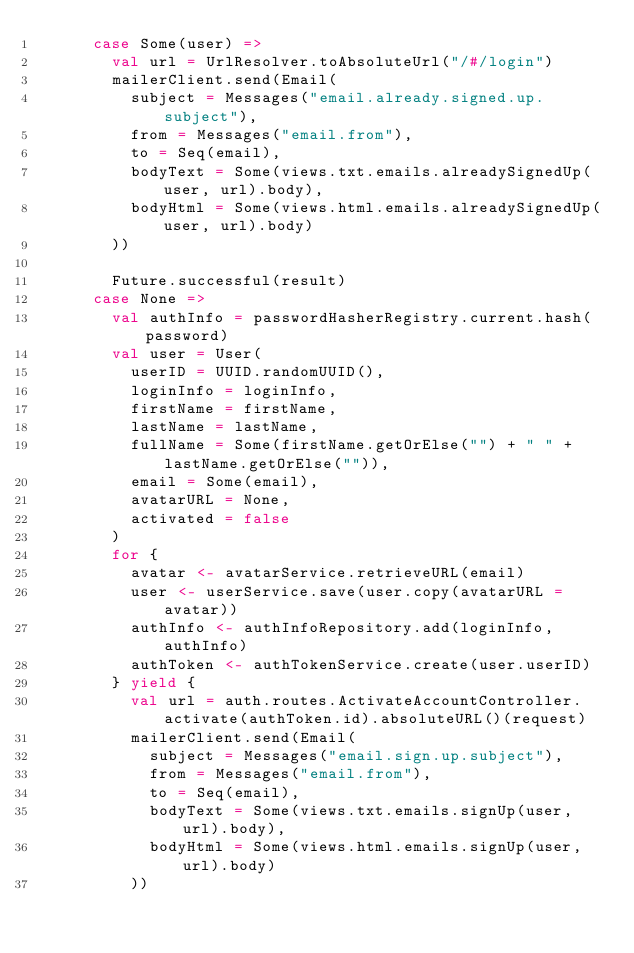Convert code to text. <code><loc_0><loc_0><loc_500><loc_500><_Scala_>      case Some(user) =>
        val url = UrlResolver.toAbsoluteUrl("/#/login")
        mailerClient.send(Email(
          subject = Messages("email.already.signed.up.subject"),
          from = Messages("email.from"),
          to = Seq(email),
          bodyText = Some(views.txt.emails.alreadySignedUp(user, url).body),
          bodyHtml = Some(views.html.emails.alreadySignedUp(user, url).body)
        ))

        Future.successful(result)
      case None =>
        val authInfo = passwordHasherRegistry.current.hash(password)
        val user = User(
          userID = UUID.randomUUID(),
          loginInfo = loginInfo,
          firstName = firstName,
          lastName = lastName,
          fullName = Some(firstName.getOrElse("") + " " + lastName.getOrElse("")),
          email = Some(email),
          avatarURL = None,
          activated = false
        )
        for {
          avatar <- avatarService.retrieveURL(email)
          user <- userService.save(user.copy(avatarURL = avatar))
          authInfo <- authInfoRepository.add(loginInfo, authInfo)
          authToken <- authTokenService.create(user.userID)
        } yield {
          val url = auth.routes.ActivateAccountController.activate(authToken.id).absoluteURL()(request)
          mailerClient.send(Email(
            subject = Messages("email.sign.up.subject"),
            from = Messages("email.from"),
            to = Seq(email),
            bodyText = Some(views.txt.emails.signUp(user, url).body),
            bodyHtml = Some(views.html.emails.signUp(user, url).body)
          ))
</code> 